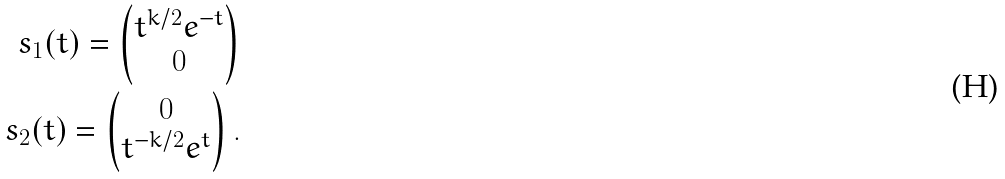<formula> <loc_0><loc_0><loc_500><loc_500>s _ { 1 } ( t ) = \left ( \begin{matrix} t ^ { k / 2 } e ^ { - t } \\ 0 \end{matrix} \right ) \\ s _ { 2 } ( t ) = \left ( \begin{matrix} 0 \\ t ^ { - k / 2 } e ^ { t } \end{matrix} \right ) .</formula> 